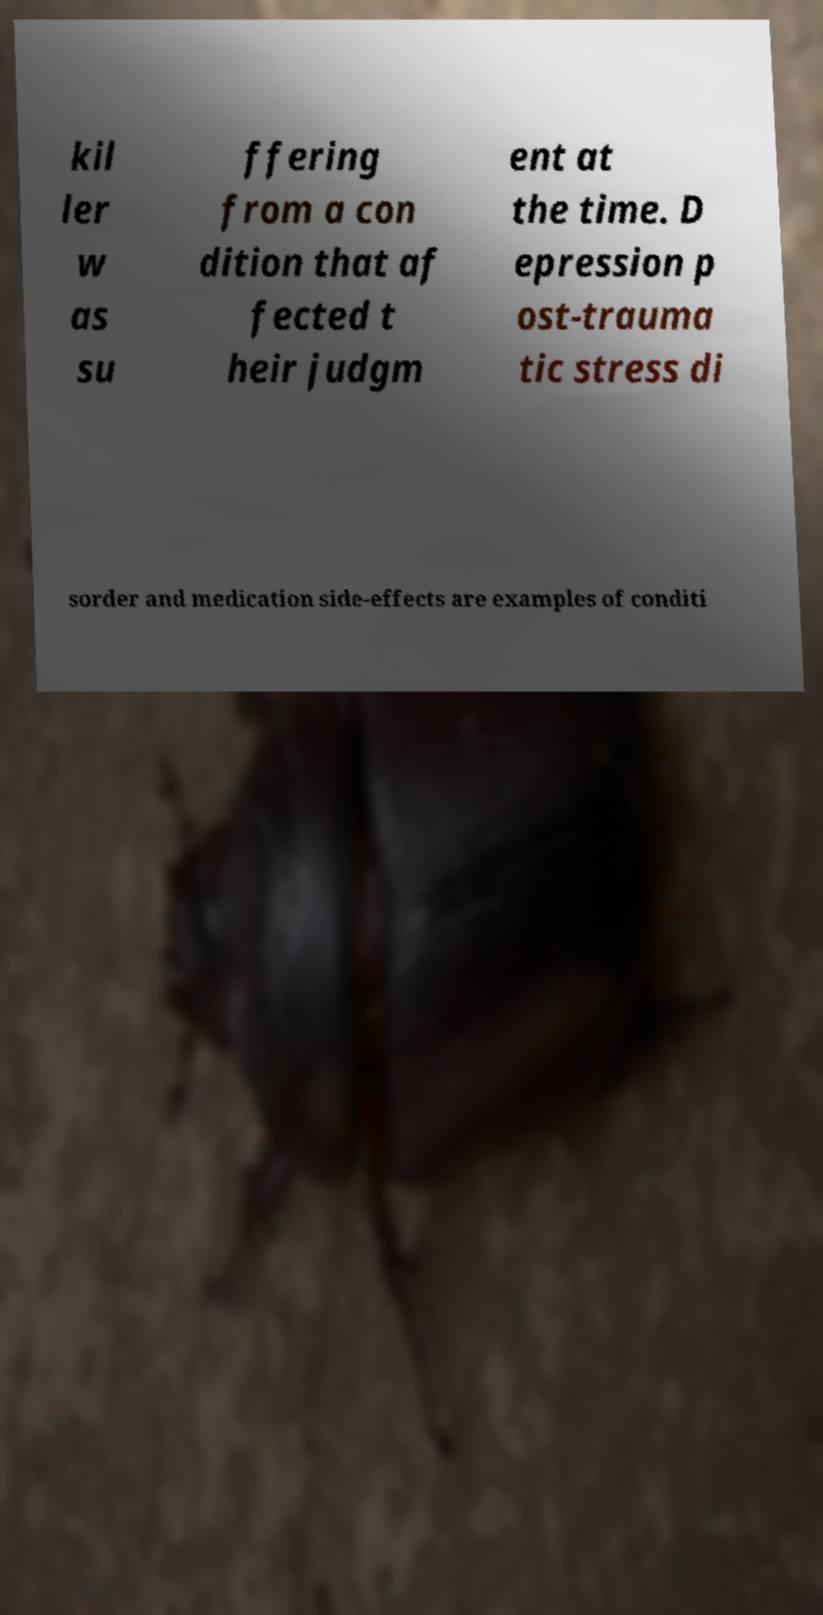Could you extract and type out the text from this image? kil ler w as su ffering from a con dition that af fected t heir judgm ent at the time. D epression p ost-trauma tic stress di sorder and medication side-effects are examples of conditi 